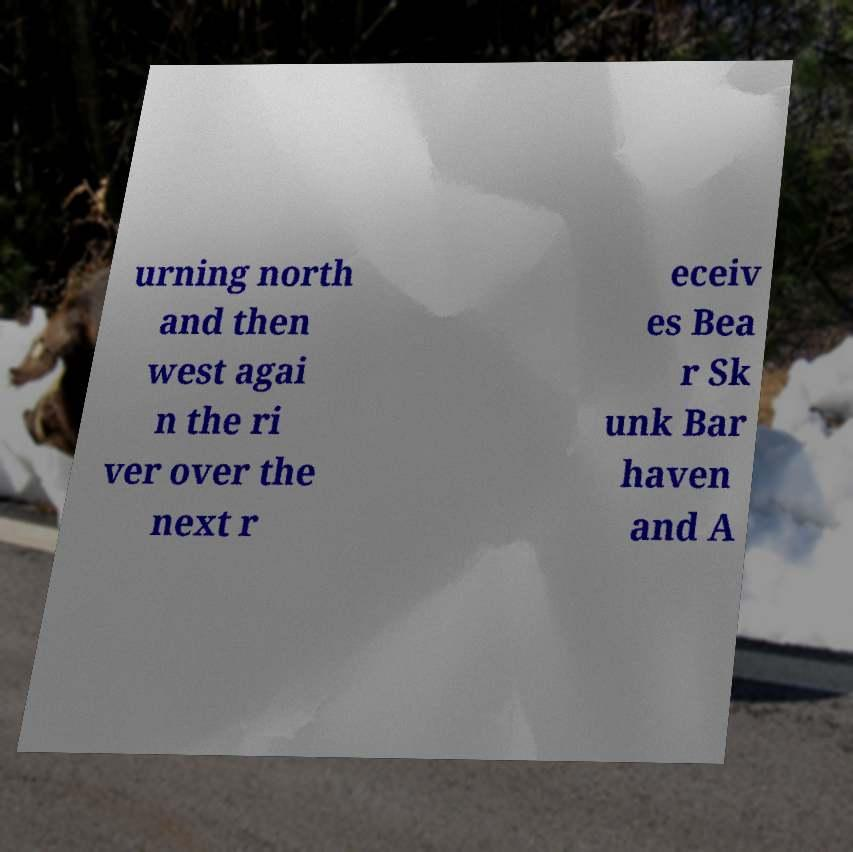For documentation purposes, I need the text within this image transcribed. Could you provide that? urning north and then west agai n the ri ver over the next r eceiv es Bea r Sk unk Bar haven and A 